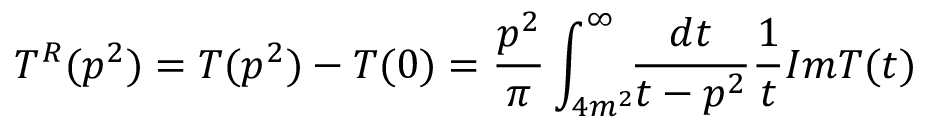<formula> <loc_0><loc_0><loc_500><loc_500>T ^ { R } ( p ^ { 2 } ) = T ( p ^ { 2 } ) - T ( 0 ) = \frac { p ^ { 2 } } { \pi } \int _ { 4 m ^ { 2 } } ^ { \infty } \, \frac { d t } { t - p ^ { 2 } } \frac { 1 } { t } I m T ( t )</formula> 